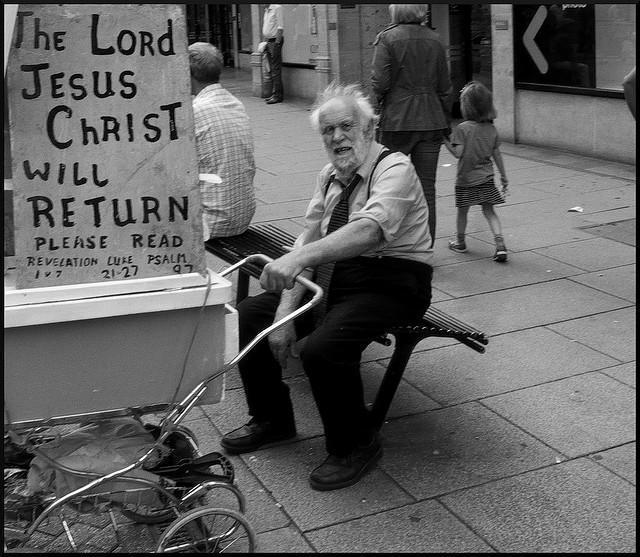How many people are in this image?
Give a very brief answer. 5. How many boards?
Give a very brief answer. 1. How many people are in the picture?
Give a very brief answer. 4. How many people holding umbrellas are in the picture?
Give a very brief answer. 0. 